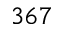Convert formula to latex. <formula><loc_0><loc_0><loc_500><loc_500>3 6 7</formula> 